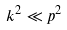<formula> <loc_0><loc_0><loc_500><loc_500>k ^ { 2 } \ll p ^ { 2 }</formula> 